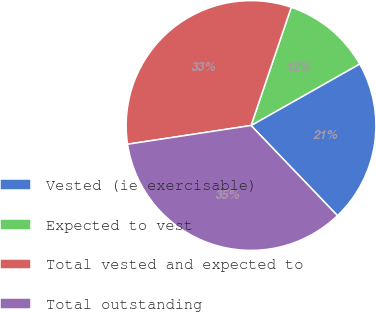Convert chart. <chart><loc_0><loc_0><loc_500><loc_500><pie_chart><fcel>Vested (ie exercisable)<fcel>Expected to vest<fcel>Total vested and expected to<fcel>Total outstanding<nl><fcel>21.04%<fcel>11.58%<fcel>32.61%<fcel>34.77%<nl></chart> 